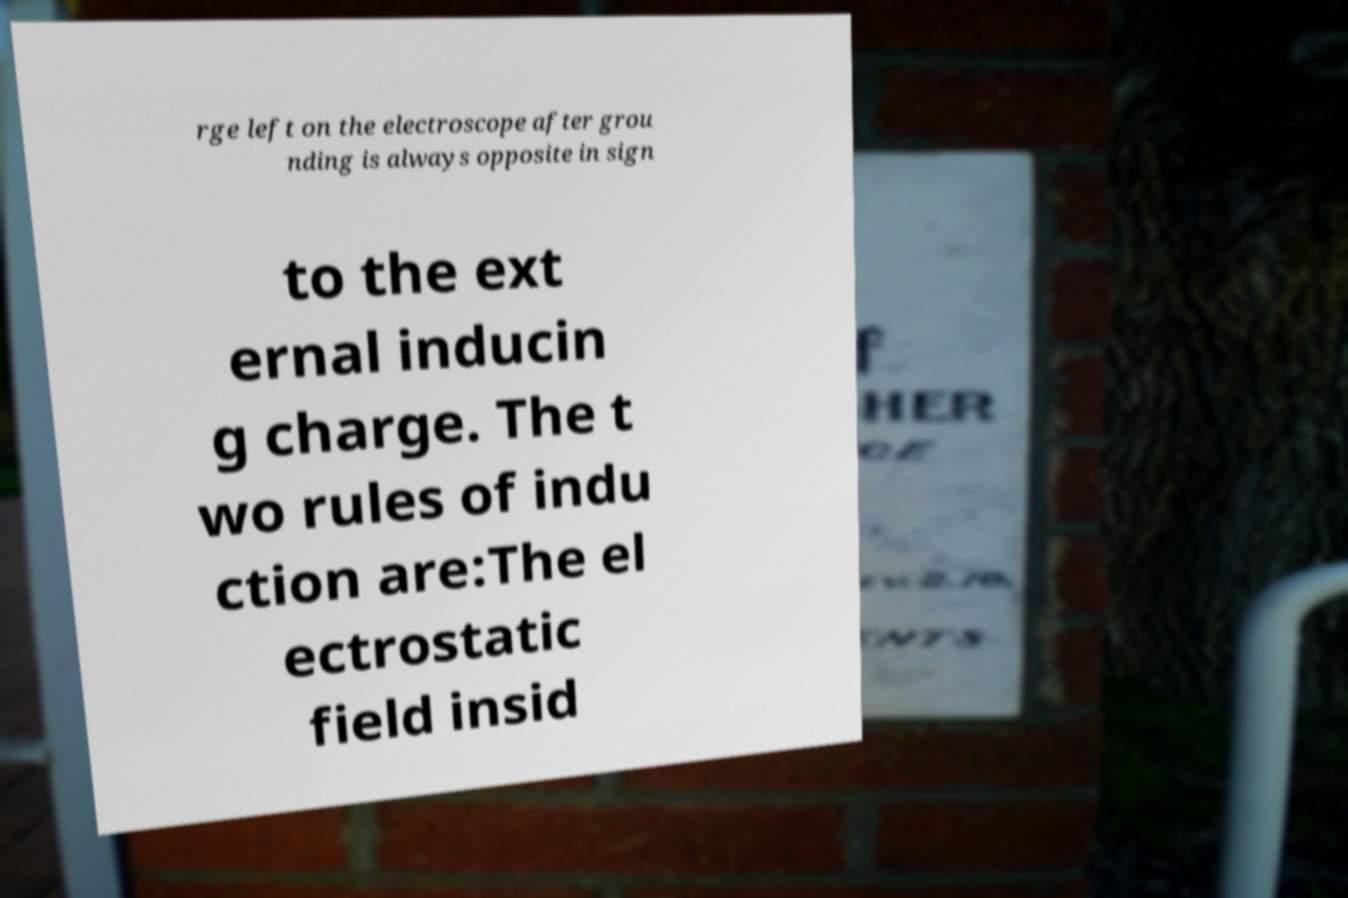Please read and relay the text visible in this image. What does it say? rge left on the electroscope after grou nding is always opposite in sign to the ext ernal inducin g charge. The t wo rules of indu ction are:The el ectrostatic field insid 